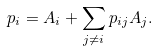Convert formula to latex. <formula><loc_0><loc_0><loc_500><loc_500>p _ { i } = A _ { i } + \sum _ { j \neq i } p _ { i j } A _ { j } .</formula> 